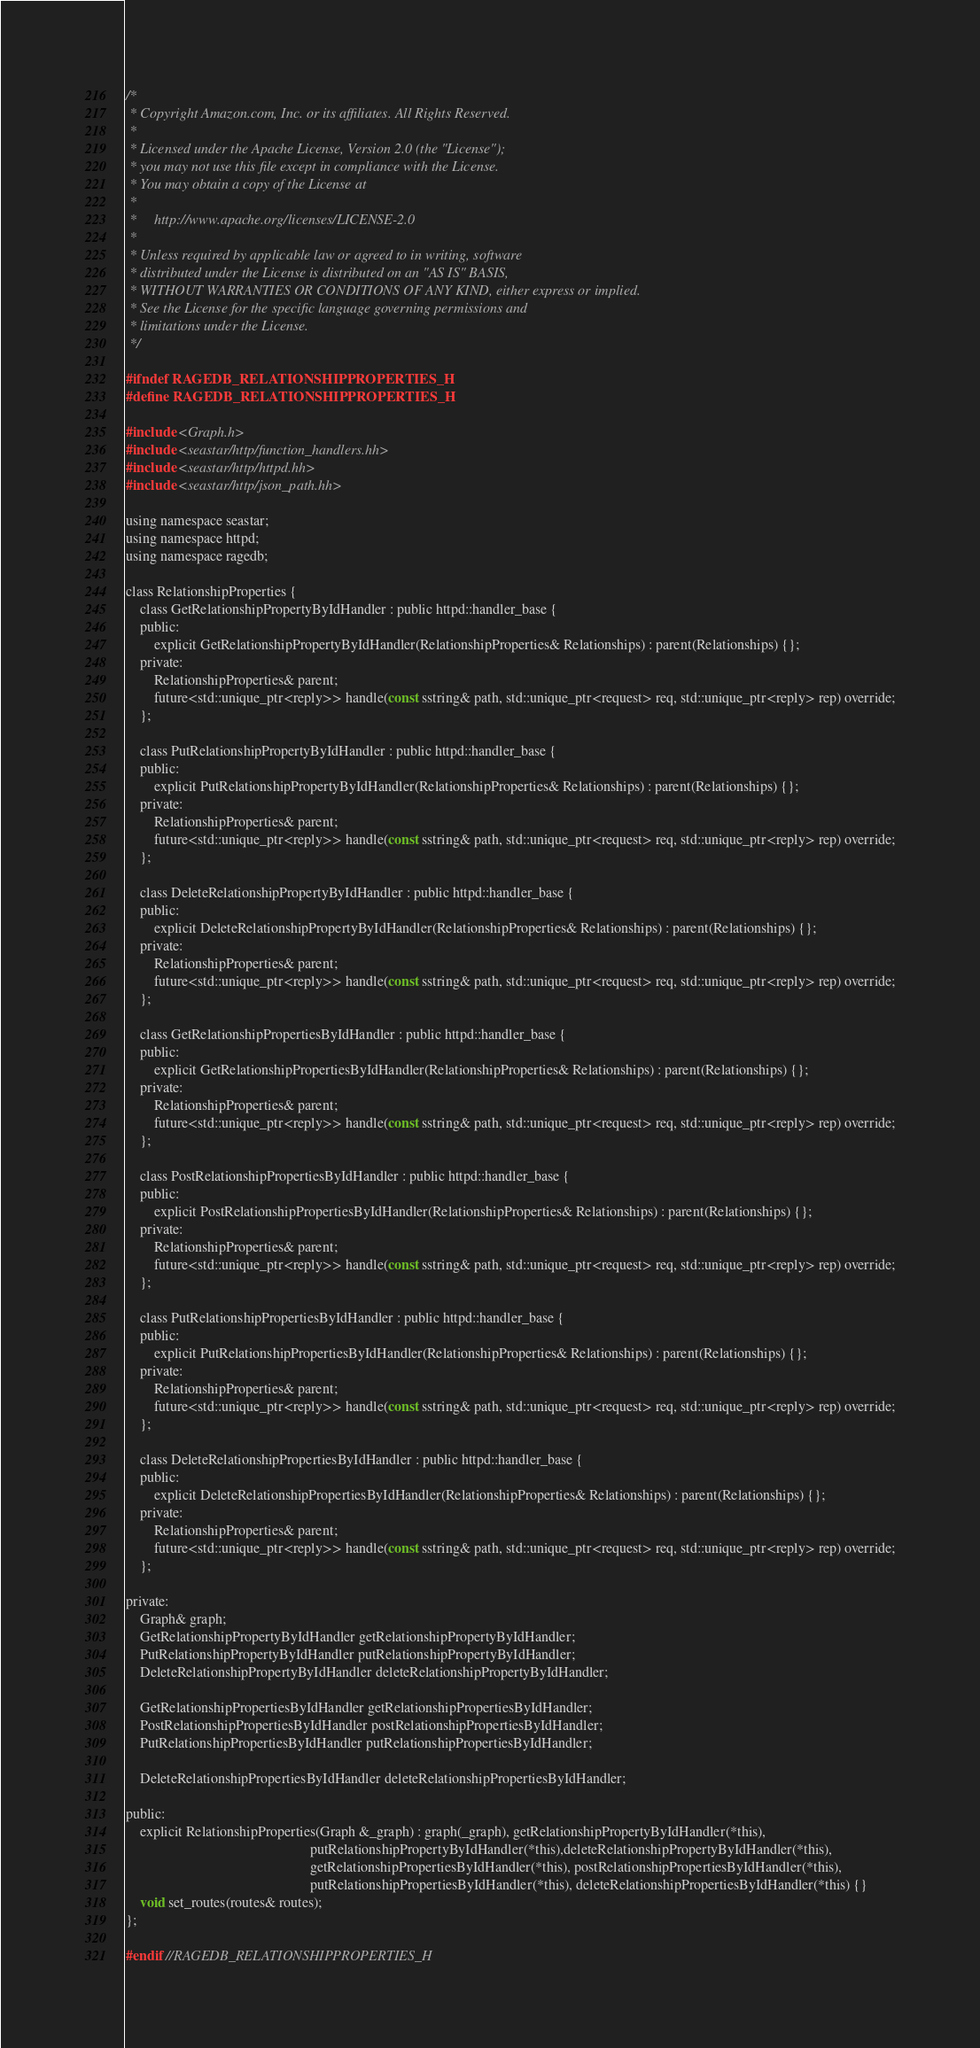Convert code to text. <code><loc_0><loc_0><loc_500><loc_500><_C_>/*
 * Copyright Amazon.com, Inc. or its affiliates. All Rights Reserved.
 *
 * Licensed under the Apache License, Version 2.0 (the "License");
 * you may not use this file except in compliance with the License.
 * You may obtain a copy of the License at
 *
 *     http://www.apache.org/licenses/LICENSE-2.0
 *
 * Unless required by applicable law or agreed to in writing, software
 * distributed under the License is distributed on an "AS IS" BASIS,
 * WITHOUT WARRANTIES OR CONDITIONS OF ANY KIND, either express or implied.
 * See the License for the specific language governing permissions and
 * limitations under the License.
 */

#ifndef RAGEDB_RELATIONSHIPPROPERTIES_H
#define RAGEDB_RELATIONSHIPPROPERTIES_H

#include <Graph.h>
#include <seastar/http/function_handlers.hh>
#include <seastar/http/httpd.hh>
#include <seastar/http/json_path.hh>

using namespace seastar;
using namespace httpd;
using namespace ragedb;

class RelationshipProperties {
    class GetRelationshipPropertyByIdHandler : public httpd::handler_base {
    public:
        explicit GetRelationshipPropertyByIdHandler(RelationshipProperties& Relationships) : parent(Relationships) {};
    private:
        RelationshipProperties& parent;
        future<std::unique_ptr<reply>> handle(const sstring& path, std::unique_ptr<request> req, std::unique_ptr<reply> rep) override;
    };

    class PutRelationshipPropertyByIdHandler : public httpd::handler_base {
    public:
        explicit PutRelationshipPropertyByIdHandler(RelationshipProperties& Relationships) : parent(Relationships) {};
    private:
        RelationshipProperties& parent;
        future<std::unique_ptr<reply>> handle(const sstring& path, std::unique_ptr<request> req, std::unique_ptr<reply> rep) override;
    };

    class DeleteRelationshipPropertyByIdHandler : public httpd::handler_base {
    public:
        explicit DeleteRelationshipPropertyByIdHandler(RelationshipProperties& Relationships) : parent(Relationships) {};
    private:
        RelationshipProperties& parent;
        future<std::unique_ptr<reply>> handle(const sstring& path, std::unique_ptr<request> req, std::unique_ptr<reply> rep) override;
    };

    class GetRelationshipPropertiesByIdHandler : public httpd::handler_base {
    public:
        explicit GetRelationshipPropertiesByIdHandler(RelationshipProperties& Relationships) : parent(Relationships) {};
    private:
        RelationshipProperties& parent;
        future<std::unique_ptr<reply>> handle(const sstring& path, std::unique_ptr<request> req, std::unique_ptr<reply> rep) override;
    };

    class PostRelationshipPropertiesByIdHandler : public httpd::handler_base {
    public:
        explicit PostRelationshipPropertiesByIdHandler(RelationshipProperties& Relationships) : parent(Relationships) {};
    private:
        RelationshipProperties& parent;
        future<std::unique_ptr<reply>> handle(const sstring& path, std::unique_ptr<request> req, std::unique_ptr<reply> rep) override;
    };

    class PutRelationshipPropertiesByIdHandler : public httpd::handler_base {
    public:
        explicit PutRelationshipPropertiesByIdHandler(RelationshipProperties& Relationships) : parent(Relationships) {};
    private:
        RelationshipProperties& parent;
        future<std::unique_ptr<reply>> handle(const sstring& path, std::unique_ptr<request> req, std::unique_ptr<reply> rep) override;
    };

    class DeleteRelationshipPropertiesByIdHandler : public httpd::handler_base {
    public:
        explicit DeleteRelationshipPropertiesByIdHandler(RelationshipProperties& Relationships) : parent(Relationships) {};
    private:
        RelationshipProperties& parent;
        future<std::unique_ptr<reply>> handle(const sstring& path, std::unique_ptr<request> req, std::unique_ptr<reply> rep) override;
    };

private:
    Graph& graph;
    GetRelationshipPropertyByIdHandler getRelationshipPropertyByIdHandler;
    PutRelationshipPropertyByIdHandler putRelationshipPropertyByIdHandler;
    DeleteRelationshipPropertyByIdHandler deleteRelationshipPropertyByIdHandler;

    GetRelationshipPropertiesByIdHandler getRelationshipPropertiesByIdHandler;
    PostRelationshipPropertiesByIdHandler postRelationshipPropertiesByIdHandler;
    PutRelationshipPropertiesByIdHandler putRelationshipPropertiesByIdHandler;

    DeleteRelationshipPropertiesByIdHandler deleteRelationshipPropertiesByIdHandler;

public:
    explicit RelationshipProperties(Graph &_graph) : graph(_graph), getRelationshipPropertyByIdHandler(*this),
                                                    putRelationshipPropertyByIdHandler(*this),deleteRelationshipPropertyByIdHandler(*this),
                                                    getRelationshipPropertiesByIdHandler(*this), postRelationshipPropertiesByIdHandler(*this),
                                                    putRelationshipPropertiesByIdHandler(*this), deleteRelationshipPropertiesByIdHandler(*this) {}
    void set_routes(routes& routes);
};

#endif //RAGEDB_RELATIONSHIPPROPERTIES_H
</code> 